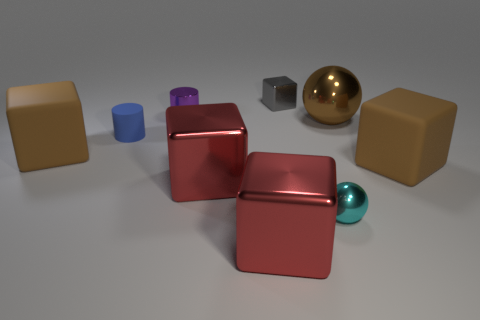Subtract all gray metal cubes. How many cubes are left? 4 Subtract all gray blocks. How many blocks are left? 4 Subtract all cyan blocks. Subtract all yellow cylinders. How many blocks are left? 5 Add 1 big brown matte blocks. How many objects exist? 10 Subtract all cylinders. How many objects are left? 7 Subtract all big brown matte things. Subtract all small matte cylinders. How many objects are left? 6 Add 7 cyan objects. How many cyan objects are left? 8 Add 5 tiny blue matte cylinders. How many tiny blue matte cylinders exist? 6 Subtract 0 green balls. How many objects are left? 9 